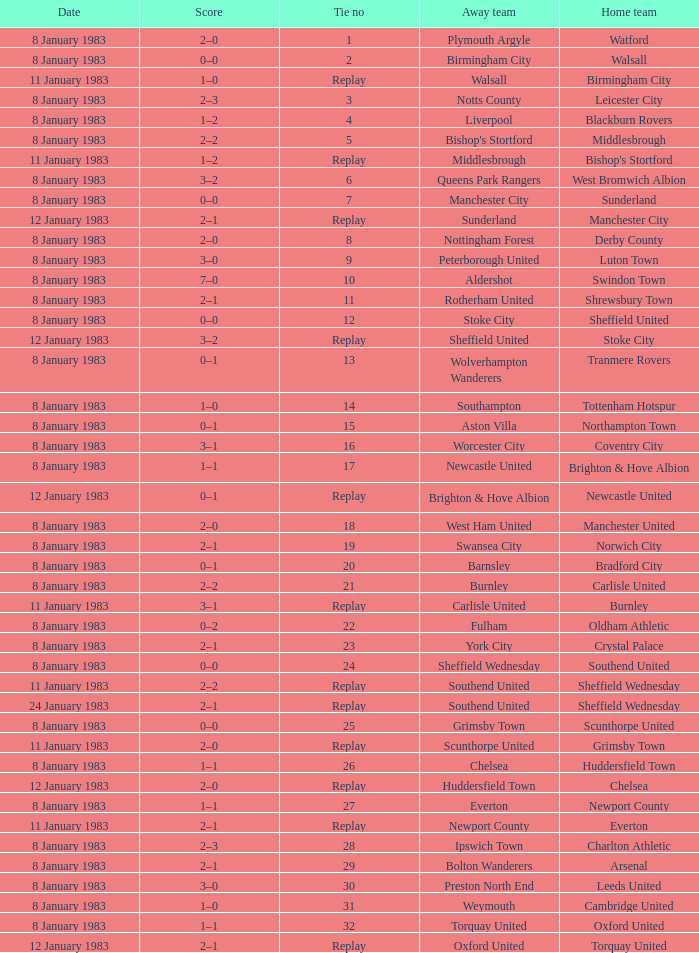What was the final score for the tie where Leeds United was the home team? 3–0. 